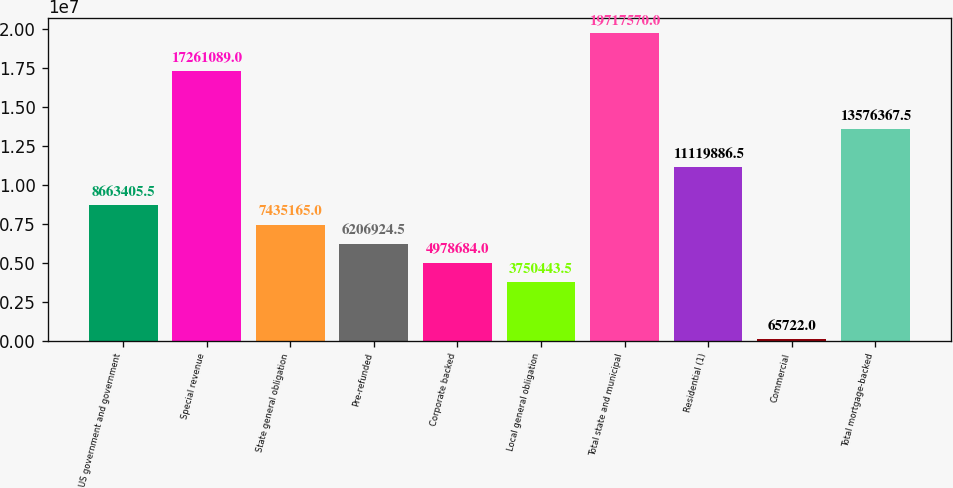<chart> <loc_0><loc_0><loc_500><loc_500><bar_chart><fcel>US government and government<fcel>Special revenue<fcel>State general obligation<fcel>Pre-refunded<fcel>Corporate backed<fcel>Local general obligation<fcel>Total state and municipal<fcel>Residential (1)<fcel>Commercial<fcel>Total mortgage-backed<nl><fcel>8.66341e+06<fcel>1.72611e+07<fcel>7.43516e+06<fcel>6.20692e+06<fcel>4.97868e+06<fcel>3.75044e+06<fcel>1.97176e+07<fcel>1.11199e+07<fcel>65722<fcel>1.35764e+07<nl></chart> 